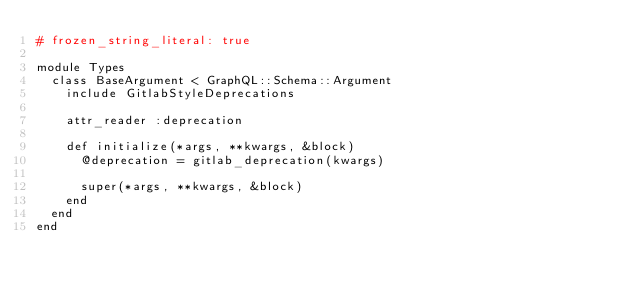Convert code to text. <code><loc_0><loc_0><loc_500><loc_500><_Ruby_># frozen_string_literal: true

module Types
  class BaseArgument < GraphQL::Schema::Argument
    include GitlabStyleDeprecations

    attr_reader :deprecation

    def initialize(*args, **kwargs, &block)
      @deprecation = gitlab_deprecation(kwargs)

      super(*args, **kwargs, &block)
    end
  end
end
</code> 